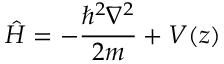Convert formula to latex. <formula><loc_0><loc_0><loc_500><loc_500>\hat { H } = - \frac { \hbar { ^ } { 2 } \nabla ^ { 2 } } { 2 m } + V ( z )</formula> 